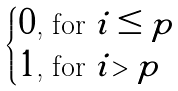<formula> <loc_0><loc_0><loc_500><loc_500>\begin{cases} 0 \text {, for } i \leq p \\ 1 \text {, for } i > p \end{cases}</formula> 